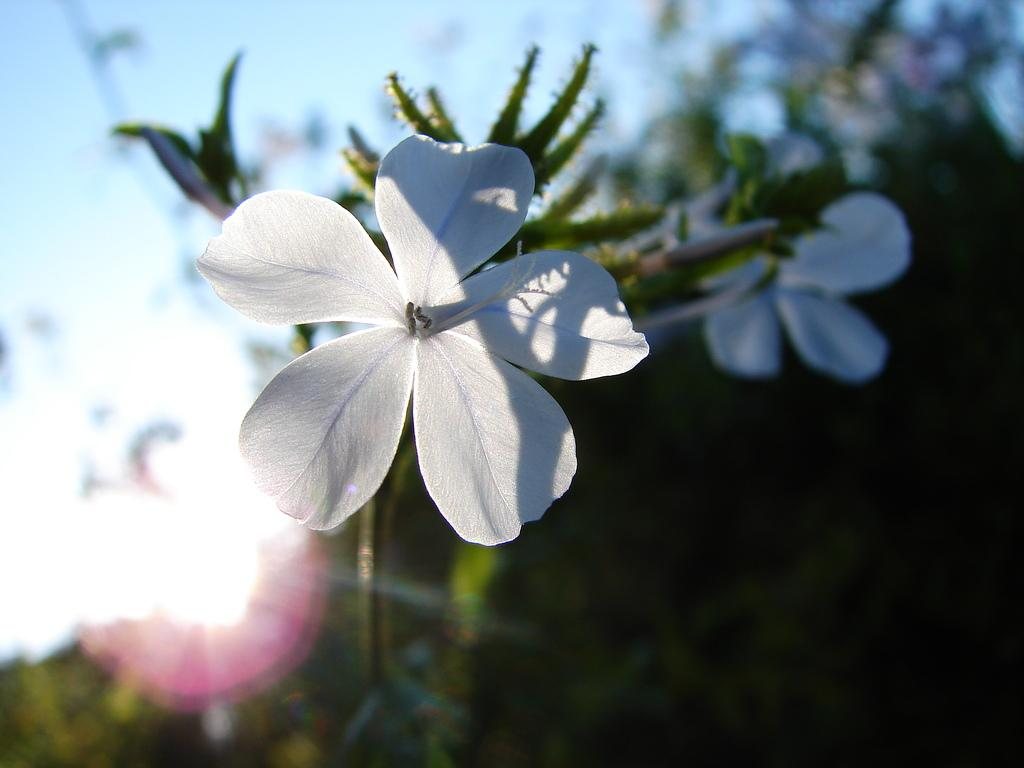What type of plants are in the image? There are flowers in the image. What color are the flowers? The flowers are white in color. What can be seen in the background of the image? The background of the image is greenery. What type of destruction can be seen in the image? There is no destruction present in the image; it features white flowers against a background of greenery. What type of ray is emitted by the flowers in the image? There are no rays emitted by the flowers in the image; they are simply white flowers in a natural setting. 